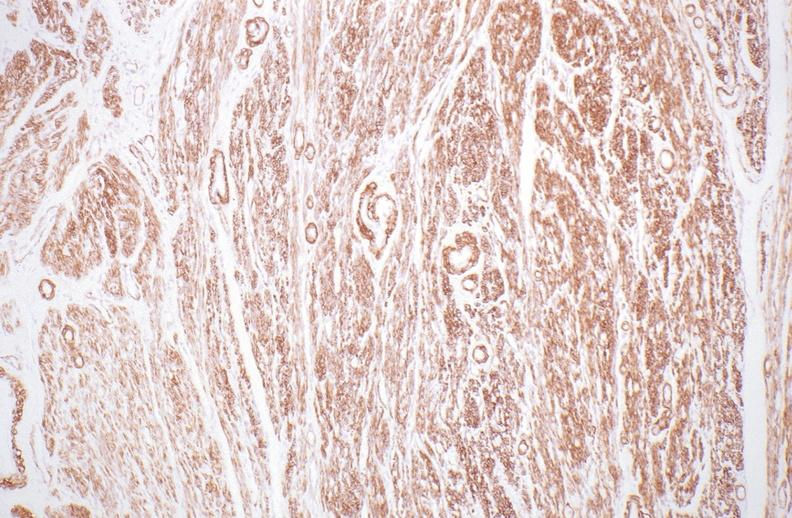does this image show normal uterus?
Answer the question using a single word or phrase. Yes 